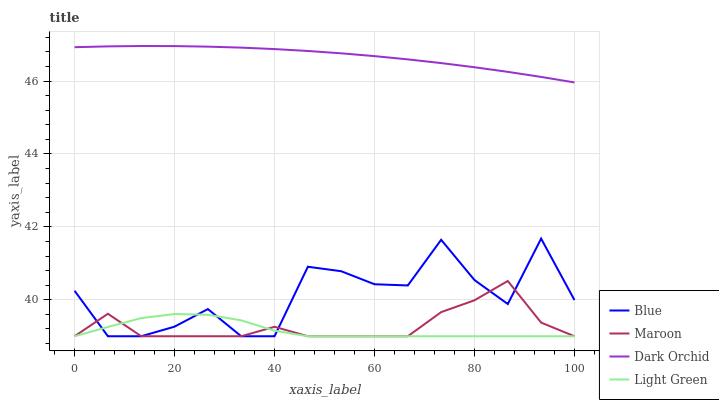Does Light Green have the minimum area under the curve?
Answer yes or no. Yes. Does Dark Orchid have the maximum area under the curve?
Answer yes or no. Yes. Does Dark Orchid have the minimum area under the curve?
Answer yes or no. No. Does Light Green have the maximum area under the curve?
Answer yes or no. No. Is Dark Orchid the smoothest?
Answer yes or no. Yes. Is Blue the roughest?
Answer yes or no. Yes. Is Light Green the smoothest?
Answer yes or no. No. Is Light Green the roughest?
Answer yes or no. No. Does Blue have the lowest value?
Answer yes or no. Yes. Does Dark Orchid have the lowest value?
Answer yes or no. No. Does Dark Orchid have the highest value?
Answer yes or no. Yes. Does Light Green have the highest value?
Answer yes or no. No. Is Light Green less than Dark Orchid?
Answer yes or no. Yes. Is Dark Orchid greater than Light Green?
Answer yes or no. Yes. Does Light Green intersect Blue?
Answer yes or no. Yes. Is Light Green less than Blue?
Answer yes or no. No. Is Light Green greater than Blue?
Answer yes or no. No. Does Light Green intersect Dark Orchid?
Answer yes or no. No. 